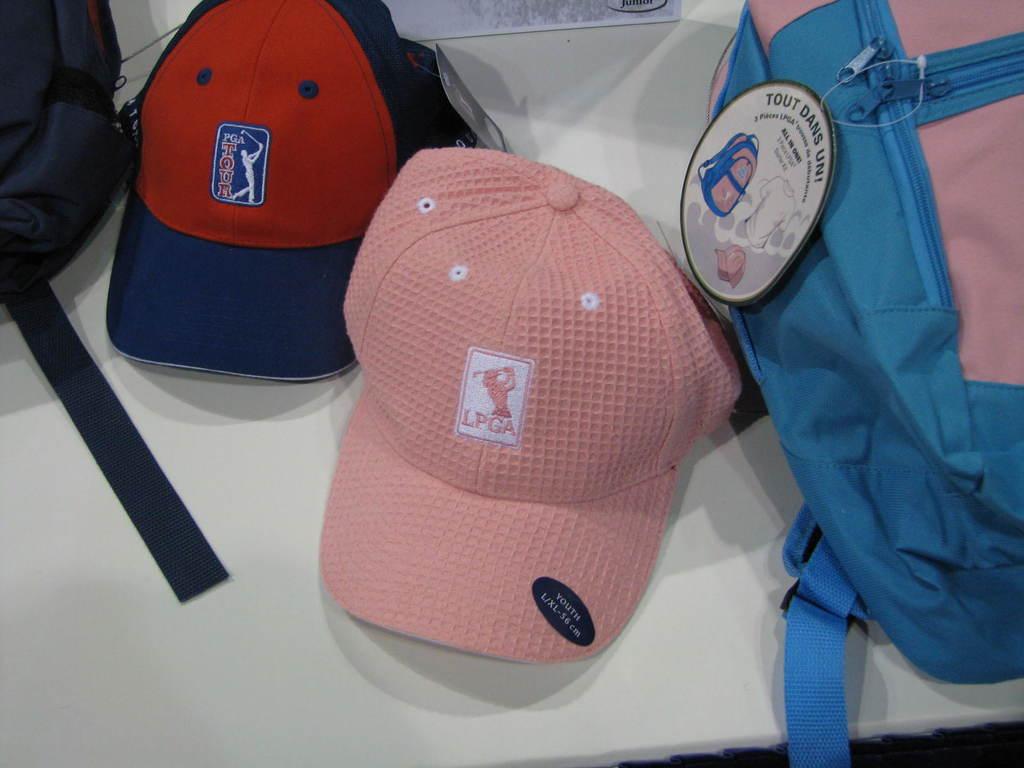Is the red hat a pga hat?
Provide a short and direct response. Yes. 